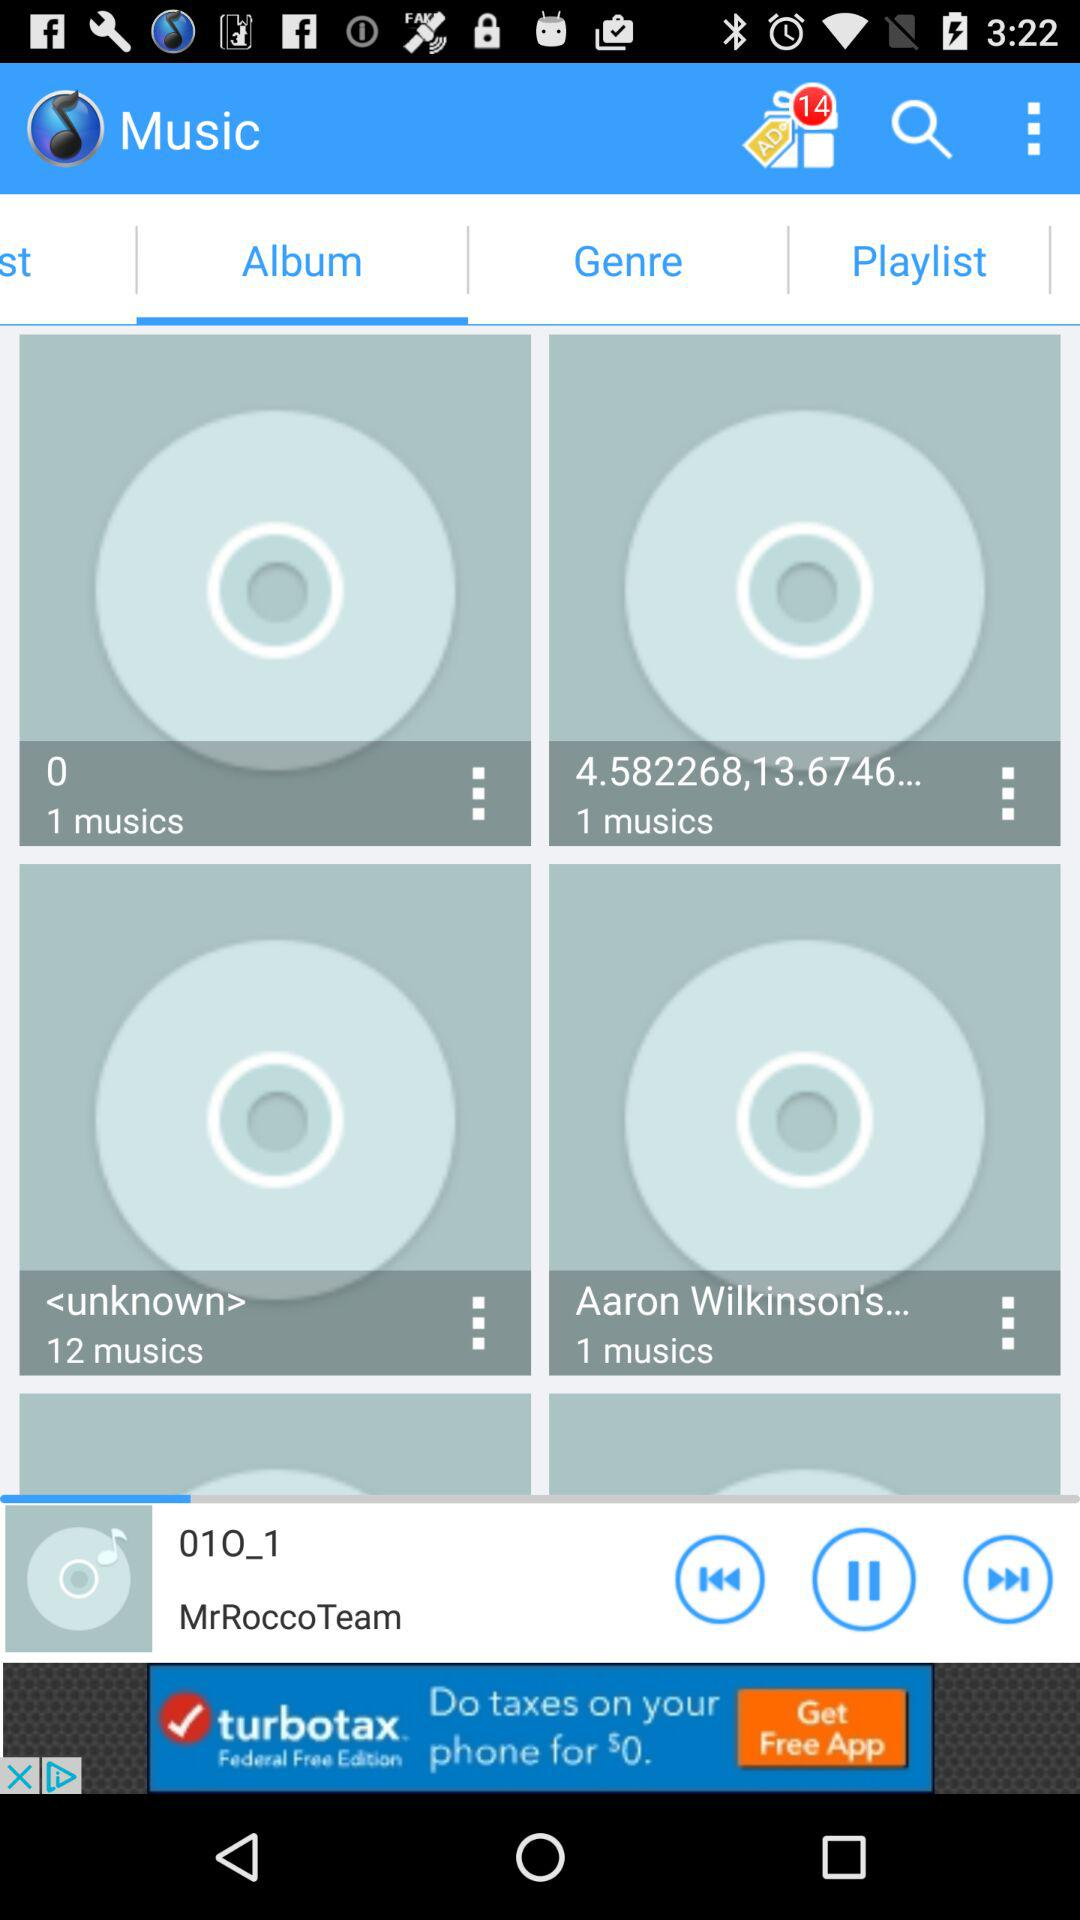How many songs are in Aron Wikinson's album? There is 1 song in Aron Wikinson's album. 